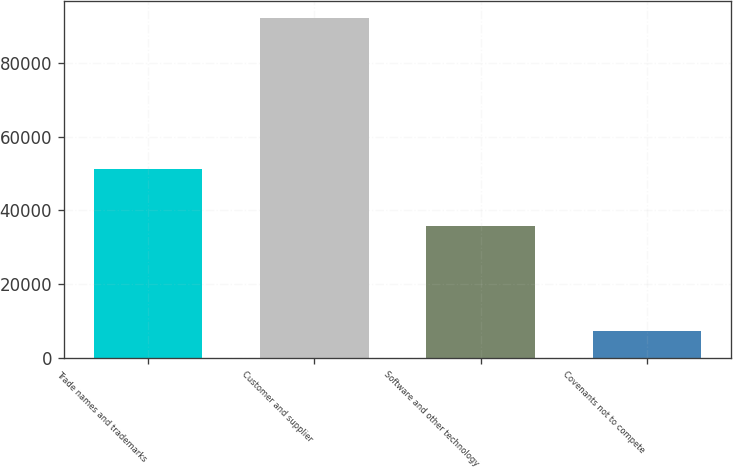Convert chart to OTSL. <chart><loc_0><loc_0><loc_500><loc_500><bar_chart><fcel>Trade names and trademarks<fcel>Customer and supplier<fcel>Software and other technology<fcel>Covenants not to compete<nl><fcel>51104<fcel>92079<fcel>35648<fcel>7285<nl></chart> 